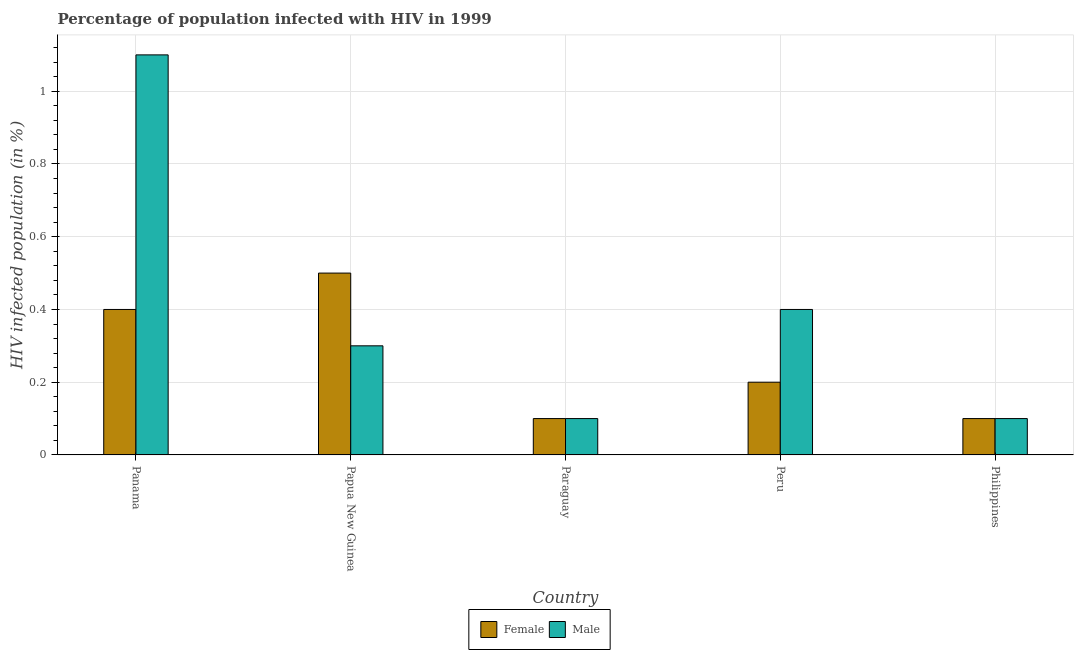How many different coloured bars are there?
Offer a terse response. 2. How many groups of bars are there?
Ensure brevity in your answer.  5. Are the number of bars on each tick of the X-axis equal?
Your answer should be very brief. Yes. How many bars are there on the 3rd tick from the left?
Offer a terse response. 2. What is the label of the 4th group of bars from the left?
Make the answer very short. Peru. In which country was the percentage of females who are infected with hiv maximum?
Your response must be concise. Papua New Guinea. In which country was the percentage of females who are infected with hiv minimum?
Ensure brevity in your answer.  Paraguay. What is the difference between the percentage of males who are infected with hiv in Papua New Guinea and that in Paraguay?
Your answer should be compact. 0.2. What is the average percentage of males who are infected with hiv per country?
Your answer should be compact. 0.4. In how many countries, is the percentage of males who are infected with hiv greater than 0.92 %?
Provide a succinct answer. 1. What is the difference between the highest and the second highest percentage of males who are infected with hiv?
Provide a short and direct response. 0.7. Is the sum of the percentage of females who are infected with hiv in Papua New Guinea and Paraguay greater than the maximum percentage of males who are infected with hiv across all countries?
Your response must be concise. No. What does the 2nd bar from the right in Peru represents?
Keep it short and to the point. Female. Does the graph contain grids?
Offer a terse response. Yes. How many legend labels are there?
Provide a short and direct response. 2. How are the legend labels stacked?
Provide a short and direct response. Horizontal. What is the title of the graph?
Your answer should be very brief. Percentage of population infected with HIV in 1999. Does "Primary education" appear as one of the legend labels in the graph?
Your answer should be compact. No. What is the label or title of the X-axis?
Your response must be concise. Country. What is the label or title of the Y-axis?
Provide a succinct answer. HIV infected population (in %). What is the HIV infected population (in %) of Male in Papua New Guinea?
Your answer should be very brief. 0.3. Across all countries, what is the maximum HIV infected population (in %) of Male?
Provide a succinct answer. 1.1. Across all countries, what is the minimum HIV infected population (in %) of Male?
Provide a short and direct response. 0.1. What is the total HIV infected population (in %) in Female in the graph?
Your answer should be compact. 1.3. What is the difference between the HIV infected population (in %) of Male in Panama and that in Papua New Guinea?
Your answer should be compact. 0.8. What is the difference between the HIV infected population (in %) in Female in Panama and that in Paraguay?
Provide a short and direct response. 0.3. What is the difference between the HIV infected population (in %) in Male in Panama and that in Paraguay?
Give a very brief answer. 1. What is the difference between the HIV infected population (in %) of Female in Papua New Guinea and that in Paraguay?
Your response must be concise. 0.4. What is the difference between the HIV infected population (in %) of Male in Papua New Guinea and that in Paraguay?
Offer a very short reply. 0.2. What is the difference between the HIV infected population (in %) of Female in Papua New Guinea and that in Peru?
Your response must be concise. 0.3. What is the difference between the HIV infected population (in %) of Female in Paraguay and that in Peru?
Offer a very short reply. -0.1. What is the difference between the HIV infected population (in %) of Male in Paraguay and that in Peru?
Keep it short and to the point. -0.3. What is the difference between the HIV infected population (in %) in Female in Paraguay and that in Philippines?
Your response must be concise. 0. What is the difference between the HIV infected population (in %) of Male in Paraguay and that in Philippines?
Your answer should be very brief. 0. What is the difference between the HIV infected population (in %) of Male in Peru and that in Philippines?
Give a very brief answer. 0.3. What is the difference between the HIV infected population (in %) in Female in Panama and the HIV infected population (in %) in Male in Paraguay?
Your answer should be compact. 0.3. What is the difference between the HIV infected population (in %) of Female in Panama and the HIV infected population (in %) of Male in Peru?
Provide a short and direct response. 0. What is the difference between the HIV infected population (in %) in Female in Panama and the HIV infected population (in %) in Male in Philippines?
Provide a succinct answer. 0.3. What is the difference between the HIV infected population (in %) of Female in Papua New Guinea and the HIV infected population (in %) of Male in Philippines?
Ensure brevity in your answer.  0.4. What is the average HIV infected population (in %) in Female per country?
Keep it short and to the point. 0.26. What is the difference between the HIV infected population (in %) in Female and HIV infected population (in %) in Male in Panama?
Offer a very short reply. -0.7. What is the difference between the HIV infected population (in %) in Female and HIV infected population (in %) in Male in Papua New Guinea?
Make the answer very short. 0.2. What is the difference between the HIV infected population (in %) of Female and HIV infected population (in %) of Male in Paraguay?
Provide a succinct answer. 0. What is the ratio of the HIV infected population (in %) of Male in Panama to that in Papua New Guinea?
Give a very brief answer. 3.67. What is the ratio of the HIV infected population (in %) of Female in Panama to that in Paraguay?
Ensure brevity in your answer.  4. What is the ratio of the HIV infected population (in %) of Female in Panama to that in Peru?
Your answer should be compact. 2. What is the ratio of the HIV infected population (in %) of Male in Panama to that in Peru?
Provide a short and direct response. 2.75. What is the ratio of the HIV infected population (in %) in Female in Panama to that in Philippines?
Provide a succinct answer. 4. What is the ratio of the HIV infected population (in %) in Male in Panama to that in Philippines?
Your response must be concise. 11. What is the ratio of the HIV infected population (in %) of Female in Papua New Guinea to that in Paraguay?
Your answer should be compact. 5. What is the ratio of the HIV infected population (in %) in Male in Papua New Guinea to that in Paraguay?
Provide a succinct answer. 3. What is the ratio of the HIV infected population (in %) of Female in Papua New Guinea to that in Peru?
Give a very brief answer. 2.5. What is the ratio of the HIV infected population (in %) in Male in Papua New Guinea to that in Philippines?
Keep it short and to the point. 3. What is the ratio of the HIV infected population (in %) of Female in Paraguay to that in Peru?
Your answer should be very brief. 0.5. What is the ratio of the HIV infected population (in %) in Male in Paraguay to that in Peru?
Your answer should be compact. 0.25. What is the ratio of the HIV infected population (in %) in Female in Paraguay to that in Philippines?
Your answer should be very brief. 1. What is the ratio of the HIV infected population (in %) in Male in Paraguay to that in Philippines?
Your answer should be compact. 1. What is the ratio of the HIV infected population (in %) in Male in Peru to that in Philippines?
Your response must be concise. 4. What is the difference between the highest and the second highest HIV infected population (in %) of Female?
Ensure brevity in your answer.  0.1. What is the difference between the highest and the second highest HIV infected population (in %) of Male?
Offer a very short reply. 0.7. What is the difference between the highest and the lowest HIV infected population (in %) of Male?
Make the answer very short. 1. 